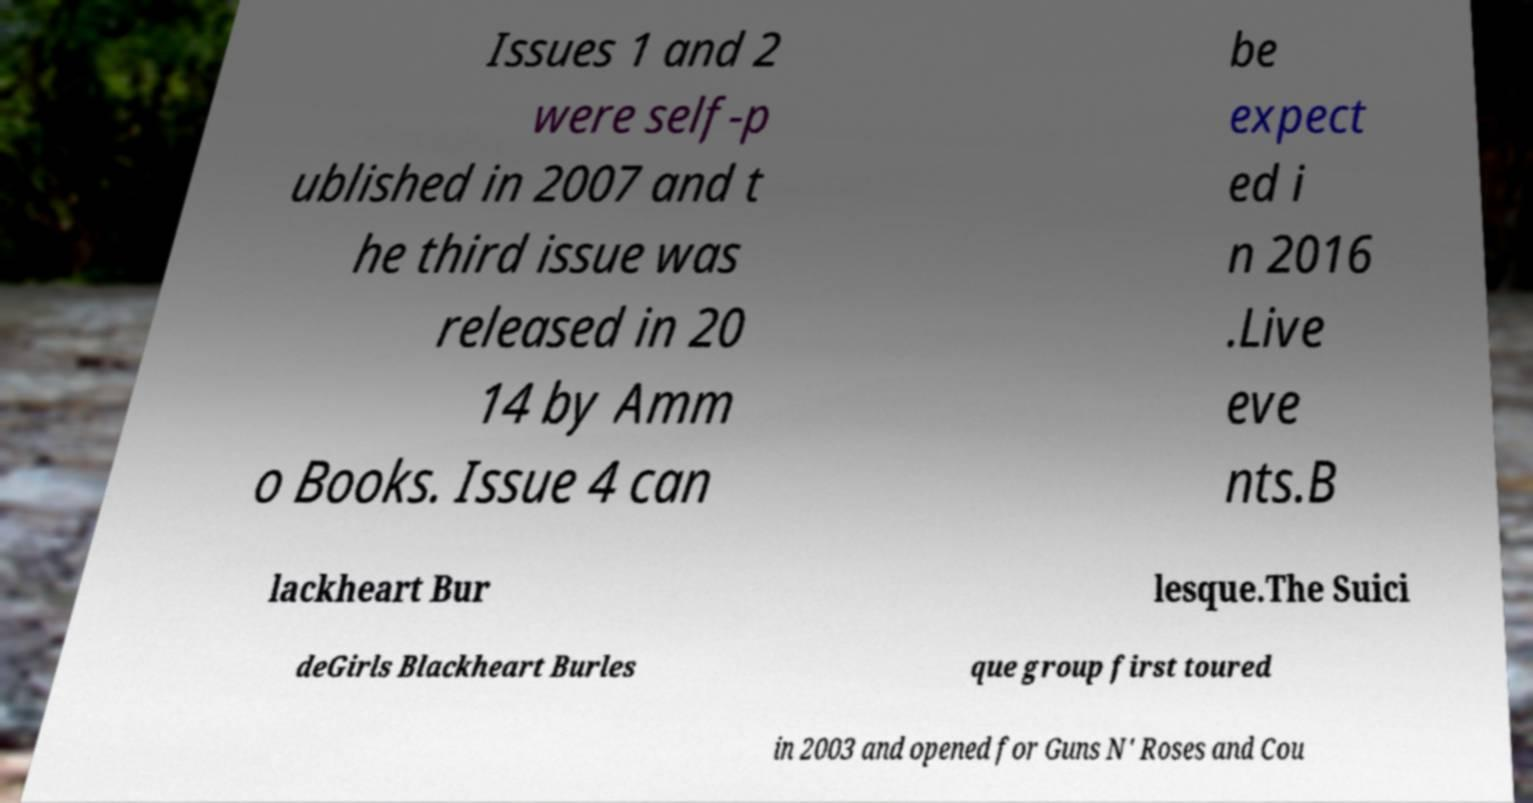There's text embedded in this image that I need extracted. Can you transcribe it verbatim? Issues 1 and 2 were self-p ublished in 2007 and t he third issue was released in 20 14 by Amm o Books. Issue 4 can be expect ed i n 2016 .Live eve nts.B lackheart Bur lesque.The Suici deGirls Blackheart Burles que group first toured in 2003 and opened for Guns N' Roses and Cou 